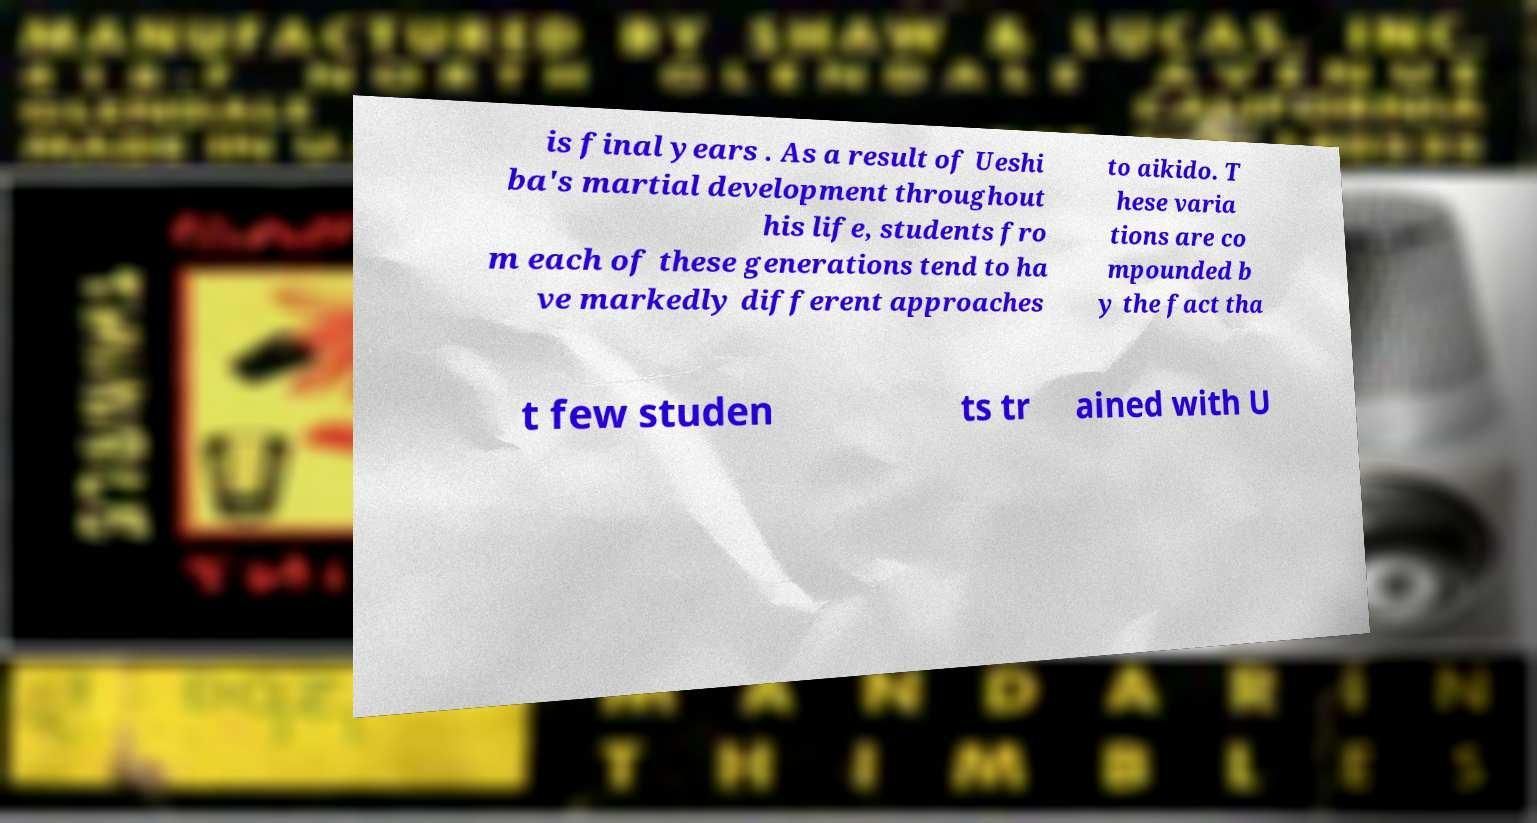Can you read and provide the text displayed in the image?This photo seems to have some interesting text. Can you extract and type it out for me? is final years . As a result of Ueshi ba's martial development throughout his life, students fro m each of these generations tend to ha ve markedly different approaches to aikido. T hese varia tions are co mpounded b y the fact tha t few studen ts tr ained with U 